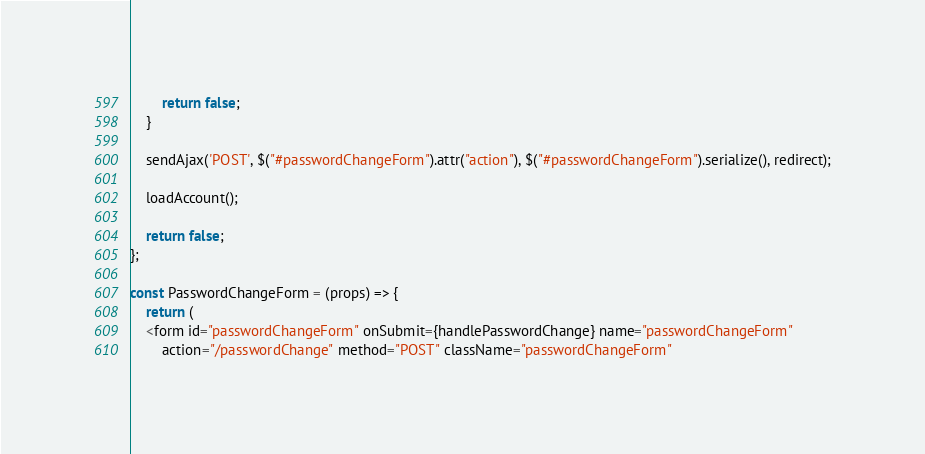Convert code to text. <code><loc_0><loc_0><loc_500><loc_500><_JavaScript_>        return false;
    }
    
    sendAjax('POST', $("#passwordChangeForm").attr("action"), $("#passwordChangeForm").serialize(), redirect);
    
    loadAccount();
    
    return false;
};

const PasswordChangeForm = (props) => {
    return (
    <form id="passwordChangeForm" onSubmit={handlePasswordChange} name="passwordChangeForm"
        action="/passwordChange" method="POST" className="passwordChangeForm"</code> 